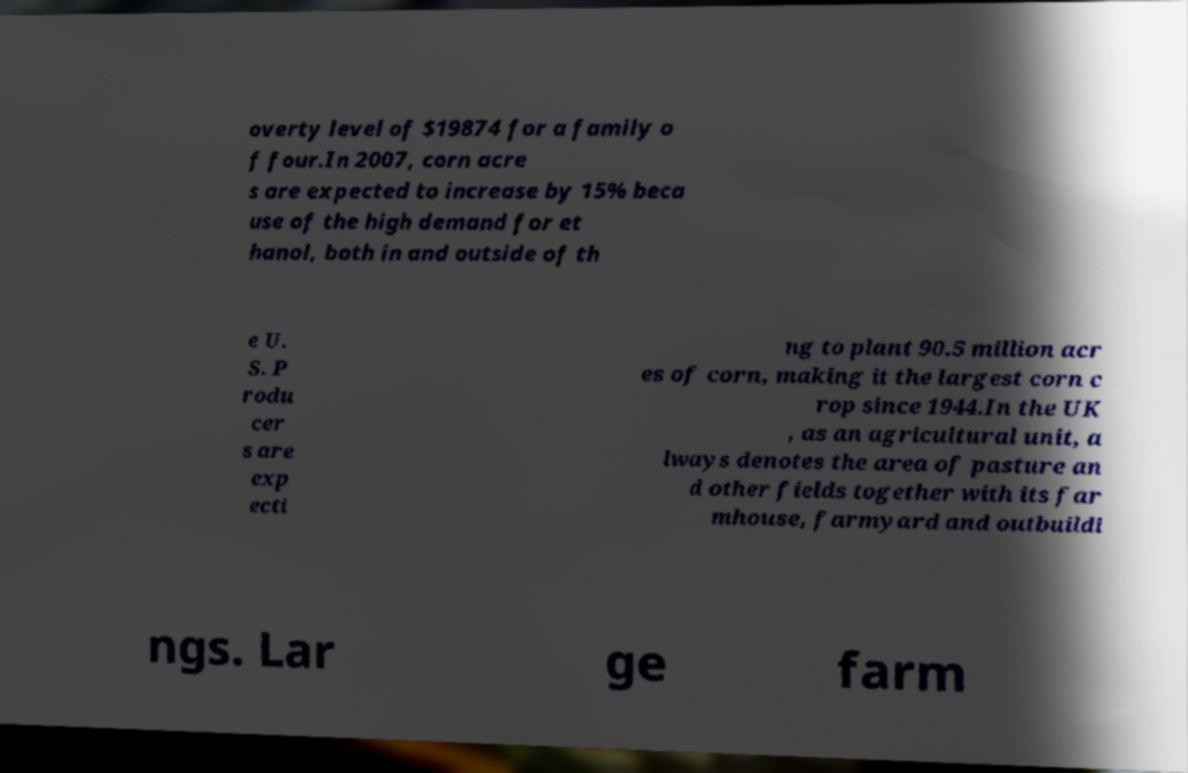There's text embedded in this image that I need extracted. Can you transcribe it verbatim? overty level of $19874 for a family o f four.In 2007, corn acre s are expected to increase by 15% beca use of the high demand for et hanol, both in and outside of th e U. S. P rodu cer s are exp ecti ng to plant 90.5 million acr es of corn, making it the largest corn c rop since 1944.In the UK , as an agricultural unit, a lways denotes the area of pasture an d other fields together with its far mhouse, farmyard and outbuildi ngs. Lar ge farm 